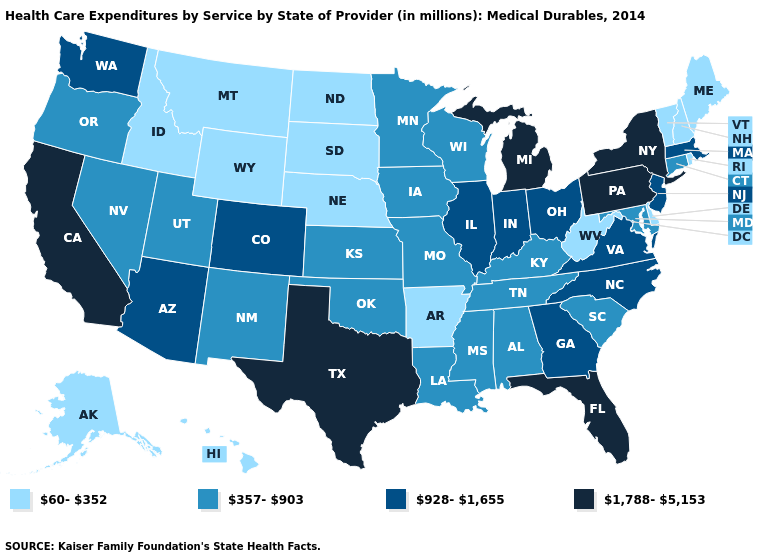Does Tennessee have the highest value in the South?
Quick response, please. No. How many symbols are there in the legend?
Give a very brief answer. 4. What is the value of Idaho?
Write a very short answer. 60-352. What is the lowest value in the South?
Give a very brief answer. 60-352. Does Ohio have a higher value than Delaware?
Answer briefly. Yes. Among the states that border New Hampshire , which have the lowest value?
Give a very brief answer. Maine, Vermont. Among the states that border New Jersey , which have the lowest value?
Keep it brief. Delaware. Does the map have missing data?
Answer briefly. No. Among the states that border Vermont , does New York have the highest value?
Concise answer only. Yes. What is the highest value in the USA?
Short answer required. 1,788-5,153. Which states have the highest value in the USA?
Quick response, please. California, Florida, Michigan, New York, Pennsylvania, Texas. What is the lowest value in the West?
Write a very short answer. 60-352. Name the states that have a value in the range 928-1,655?
Be succinct. Arizona, Colorado, Georgia, Illinois, Indiana, Massachusetts, New Jersey, North Carolina, Ohio, Virginia, Washington. Which states have the lowest value in the Northeast?
Short answer required. Maine, New Hampshire, Rhode Island, Vermont. What is the value of Maryland?
Keep it brief. 357-903. 